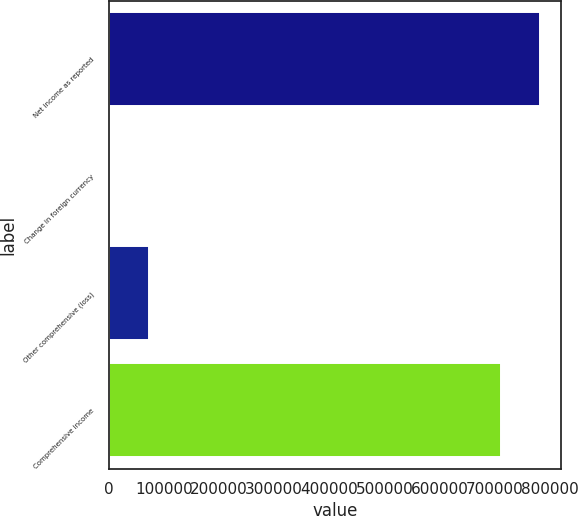Convert chart. <chart><loc_0><loc_0><loc_500><loc_500><bar_chart><fcel>Net income as reported<fcel>Change in foreign currency<fcel>Other comprehensive (loss)<fcel>Comprehensive income<nl><fcel>782465<fcel>1178<fcel>72328.7<fcel>711314<nl></chart> 